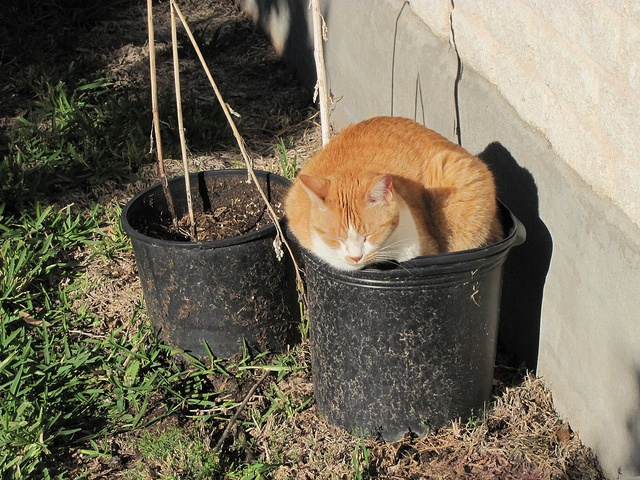Describe the objects in this image and their specific colors. I can see potted plant in black, gray, and darkgray tones, potted plant in black and gray tones, and cat in black and tan tones in this image. 